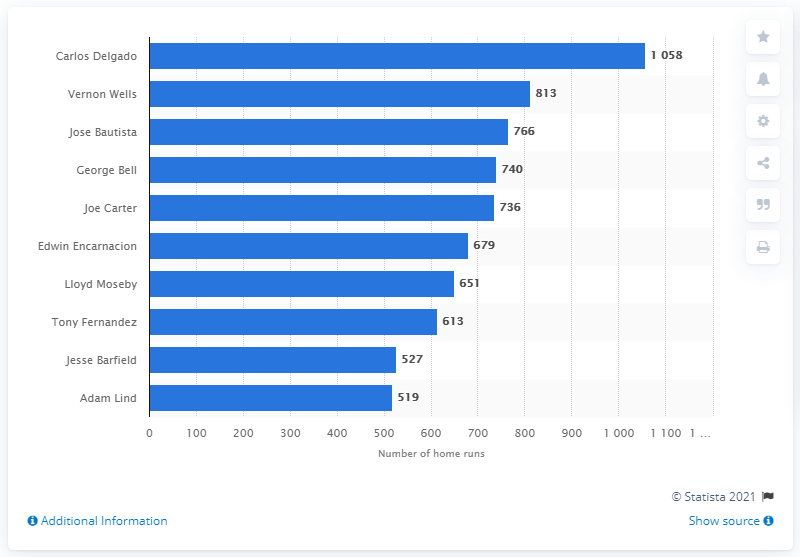Can you explain why some of these players are considered legendary for the Toronto Blue Jays? Players like Carlos Delgado, Vernon Wells, and Jose Bautista are considered legendary for the Toronto Blue Jays due to their impressive performance during their careers. Delgado leads with home runs, Wells provided consistent hitting and high home run counts, and Bautista is memorable for his powerful batting and key moments such as his famous bat flip in the 2015 playoffs. 